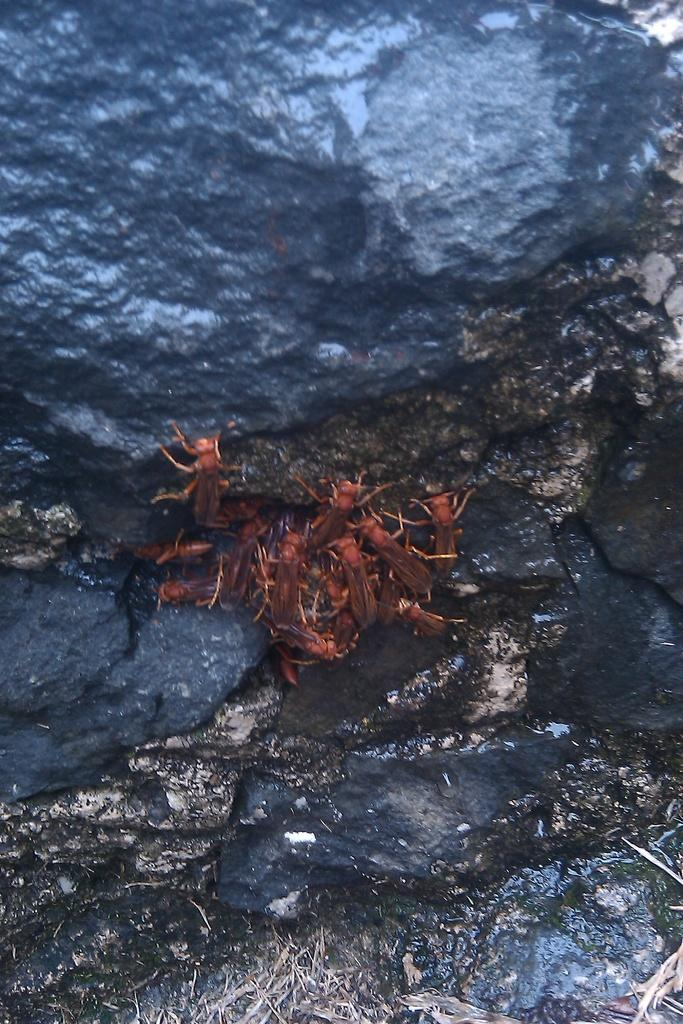What is at the bottom of the image? There is dry grass and stones at the bottom of the image. What can be found in the middle of the image? Insects in brown color are present in the middle of the image. What is located in the background of the image? There is a rock in black color in the background of the image. What type of furniture can be seen in the image? There is no furniture present in the image; it features dry grass, stones, insects, and a rock. What song is being played in the background of the image? There is no song playing in the background of the image; it is a still image of dry grass, stones, insects, and a rock. 